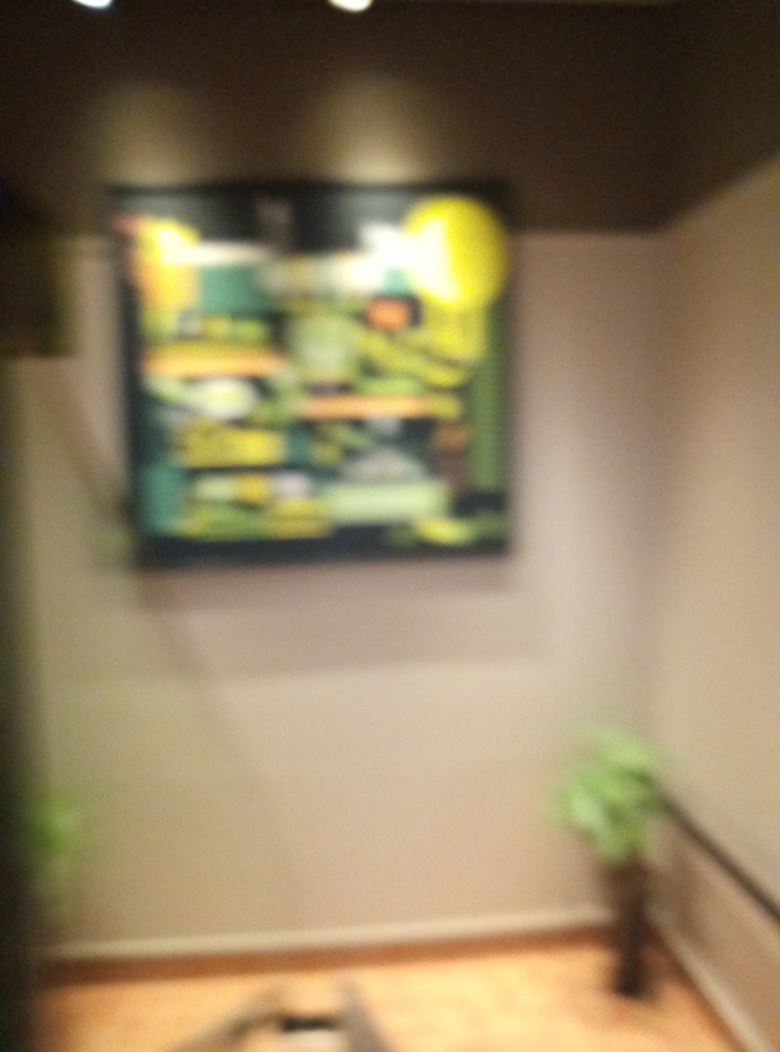Can you see details clearly in the image? Based on the image's quality, it's not possible to make out details clearly, as the picture is quite blurred. This could be intentional for artistic effect or an accidental camera shake. The essence of the image suggests a framed artwork or poster on a wall, viewed from an angle. Some ambient lighting can be seen at the top, and there appears to be a small potted plant at the bottom right. 